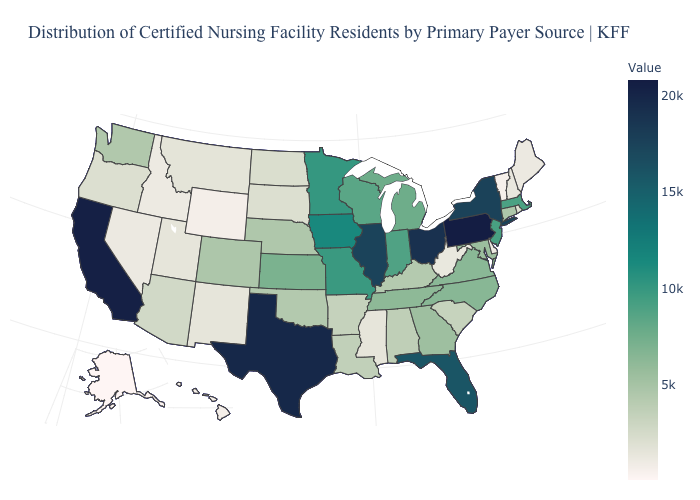Does Ohio have the highest value in the MidWest?
Answer briefly. Yes. Does Alaska have the lowest value in the USA?
Answer briefly. Yes. Which states have the lowest value in the USA?
Concise answer only. Alaska. Does Maryland have a lower value than Massachusetts?
Keep it brief. Yes. Does Tennessee have the lowest value in the USA?
Answer briefly. No. Among the states that border California , does Oregon have the highest value?
Give a very brief answer. No. Is the legend a continuous bar?
Give a very brief answer. Yes. Is the legend a continuous bar?
Short answer required. Yes. 